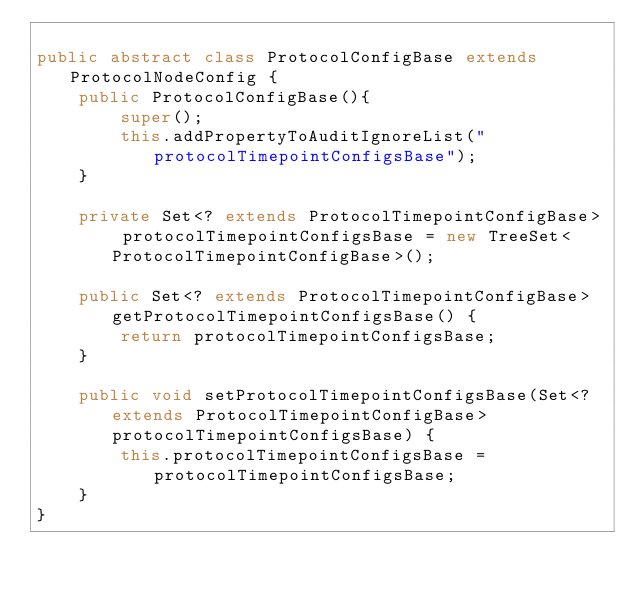<code> <loc_0><loc_0><loc_500><loc_500><_Java_>
public abstract class ProtocolConfigBase extends ProtocolNodeConfig {
	public ProtocolConfigBase(){
		super();
		this.addPropertyToAuditIgnoreList("protocolTimepointConfigsBase");
	}
	
	private Set<? extends ProtocolTimepointConfigBase> protocolTimepointConfigsBase = new TreeSet<ProtocolTimepointConfigBase>();
	
	public Set<? extends ProtocolTimepointConfigBase> getProtocolTimepointConfigsBase() {
		return protocolTimepointConfigsBase;
	}

	public void setProtocolTimepointConfigsBase(Set<? extends ProtocolTimepointConfigBase> protocolTimepointConfigsBase) {
		this.protocolTimepointConfigsBase = protocolTimepointConfigsBase;
	}
}
</code> 